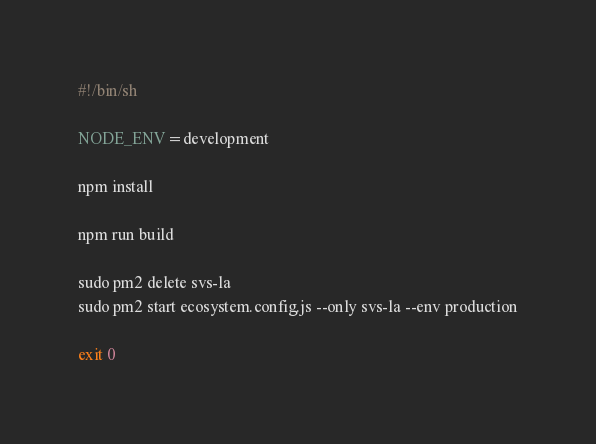<code> <loc_0><loc_0><loc_500><loc_500><_Bash_>#!/bin/sh

NODE_ENV=development

npm install

npm run build

sudo pm2 delete svs-la
sudo pm2 start ecosystem.config.js --only svs-la --env production

exit 0
</code> 